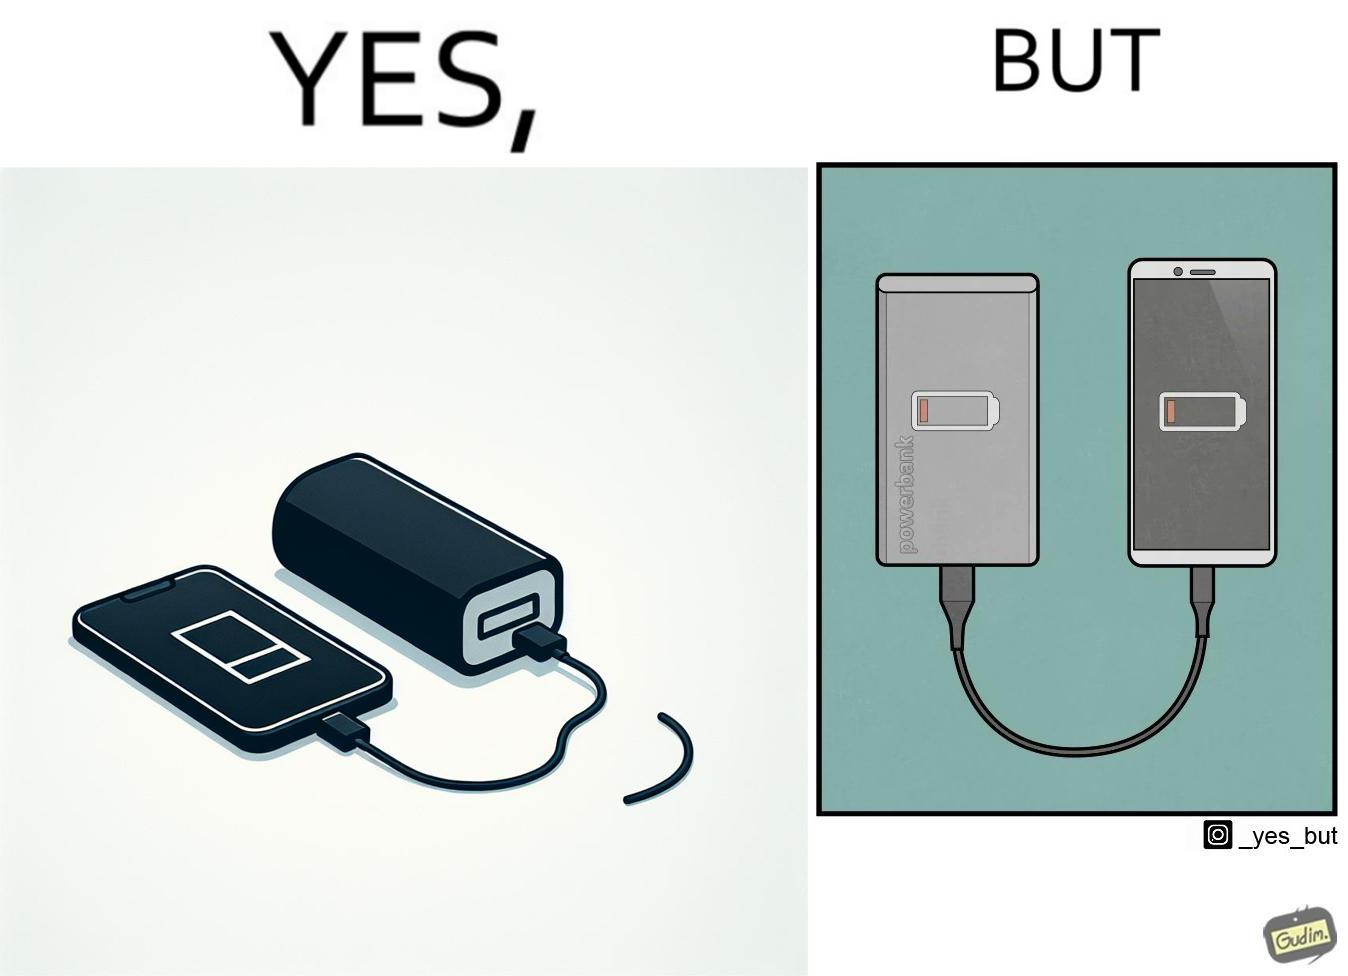Explain why this image is satirical. This image is funny because its an assumed expectation that  the dead phone will be rescued by the power bank, but here the power bank is also dead and of no use. 